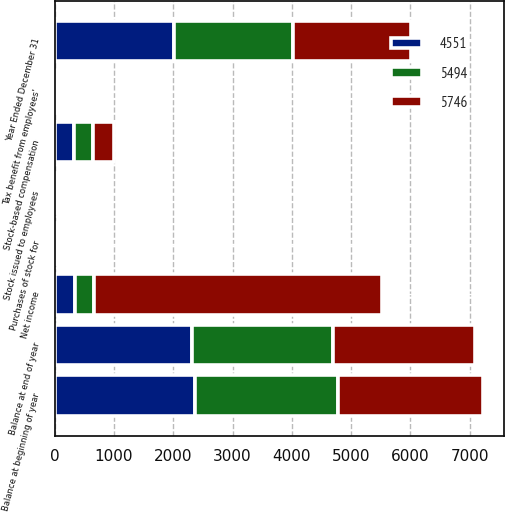<chart> <loc_0><loc_0><loc_500><loc_500><stacked_bar_chart><ecel><fcel>Year Ended December 31<fcel>Balance at beginning of year<fcel>Stock issued to employees<fcel>Purchases of stock for<fcel>Balance at end of year<fcel>Tax benefit from employees'<fcel>Stock-based compensation<fcel>Net income<nl><fcel>4551<fcel>2006<fcel>2369<fcel>4<fcel>55<fcel>2318<fcel>3<fcel>324<fcel>334.5<nl><fcel>5494<fcel>2005<fcel>2409<fcel>7<fcel>47<fcel>2369<fcel>11<fcel>324<fcel>334.5<nl><fcel>5746<fcel>2004<fcel>2442<fcel>5<fcel>38<fcel>2409<fcel>13<fcel>345<fcel>4847<nl></chart> 